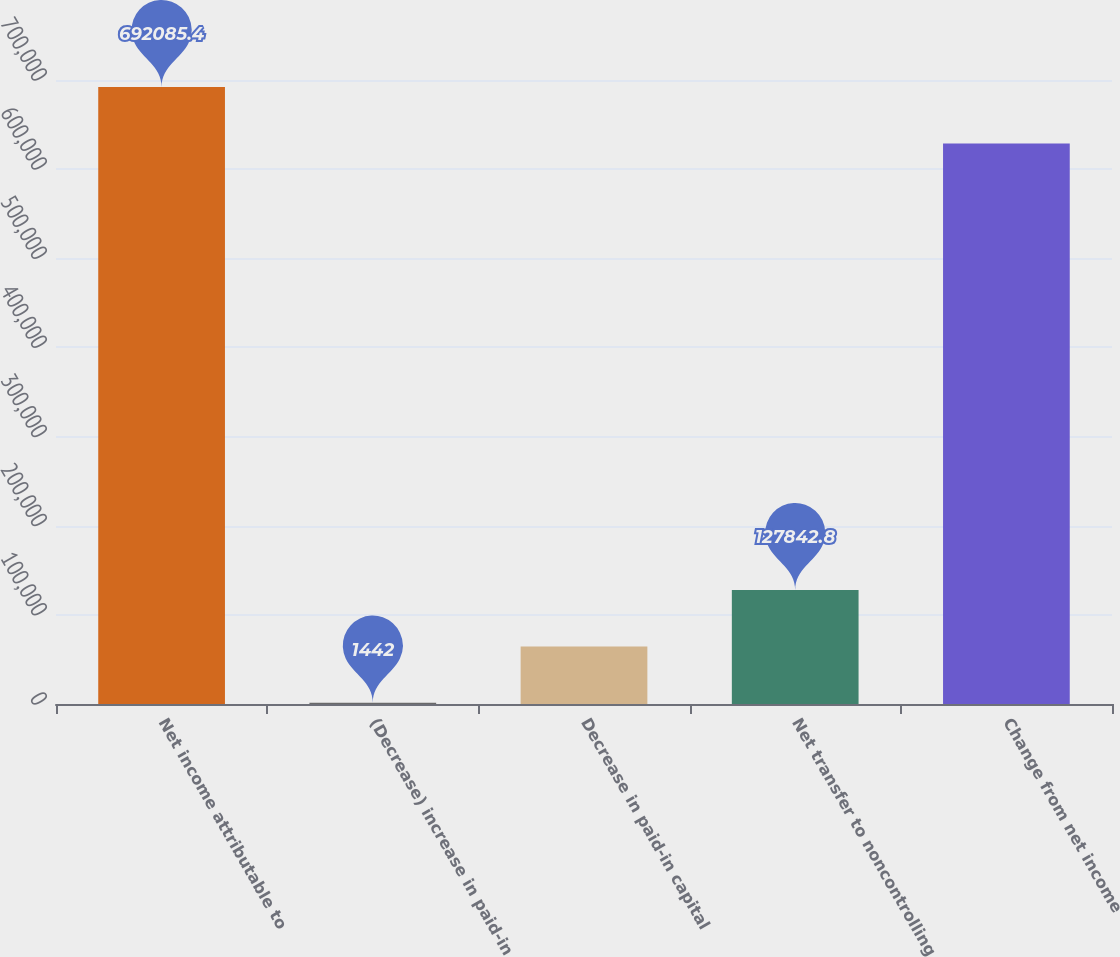<chart> <loc_0><loc_0><loc_500><loc_500><bar_chart><fcel>Net income attributable to<fcel>(Decrease) increase in paid-in<fcel>Decrease in paid-in capital<fcel>Net transfer to noncontrolling<fcel>Change from net income<nl><fcel>692085<fcel>1442<fcel>64642.4<fcel>127843<fcel>628885<nl></chart> 